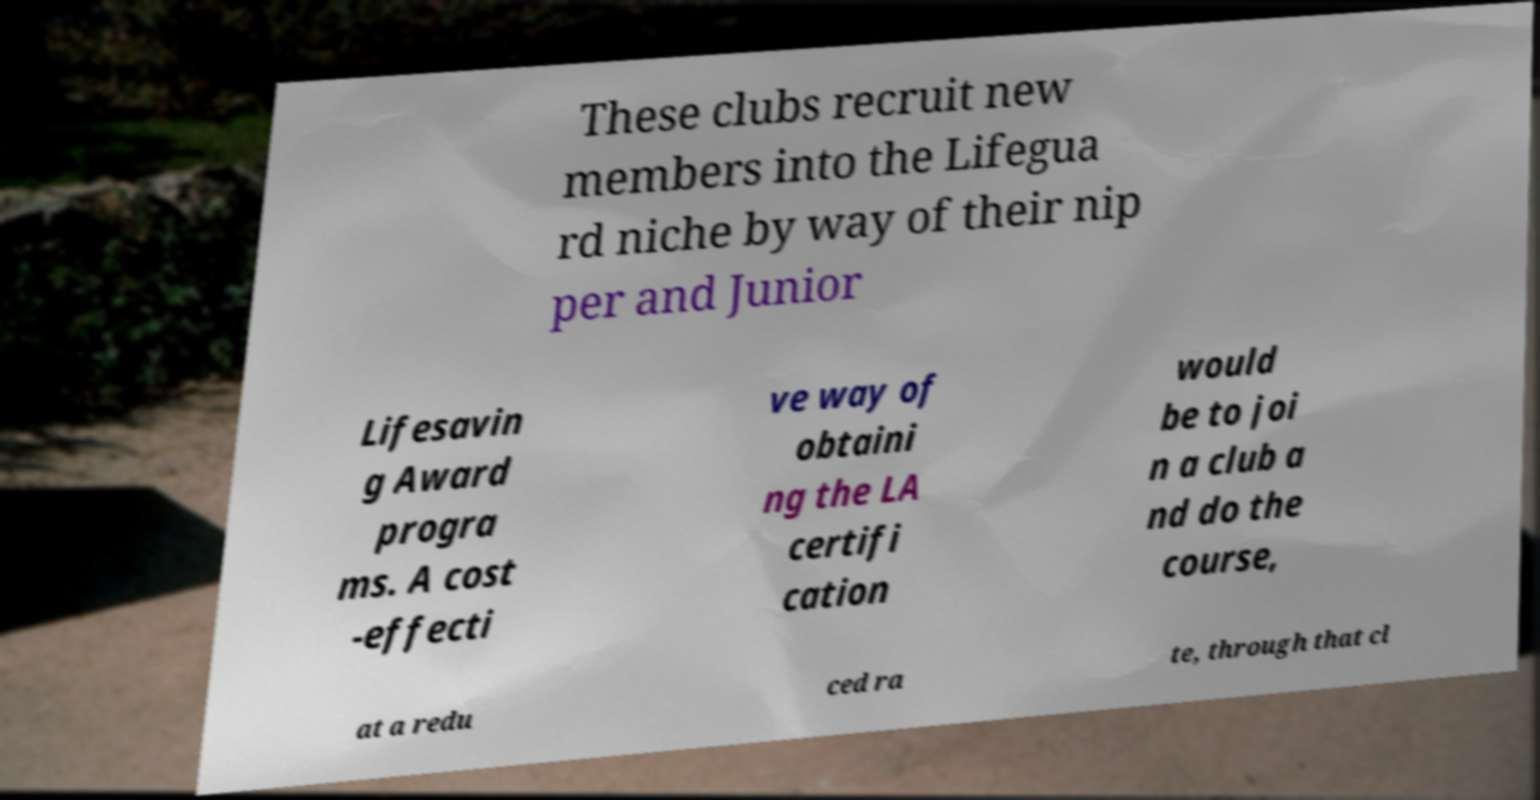Could you assist in decoding the text presented in this image and type it out clearly? These clubs recruit new members into the Lifegua rd niche by way of their nip per and Junior Lifesavin g Award progra ms. A cost -effecti ve way of obtaini ng the LA certifi cation would be to joi n a club a nd do the course, at a redu ced ra te, through that cl 